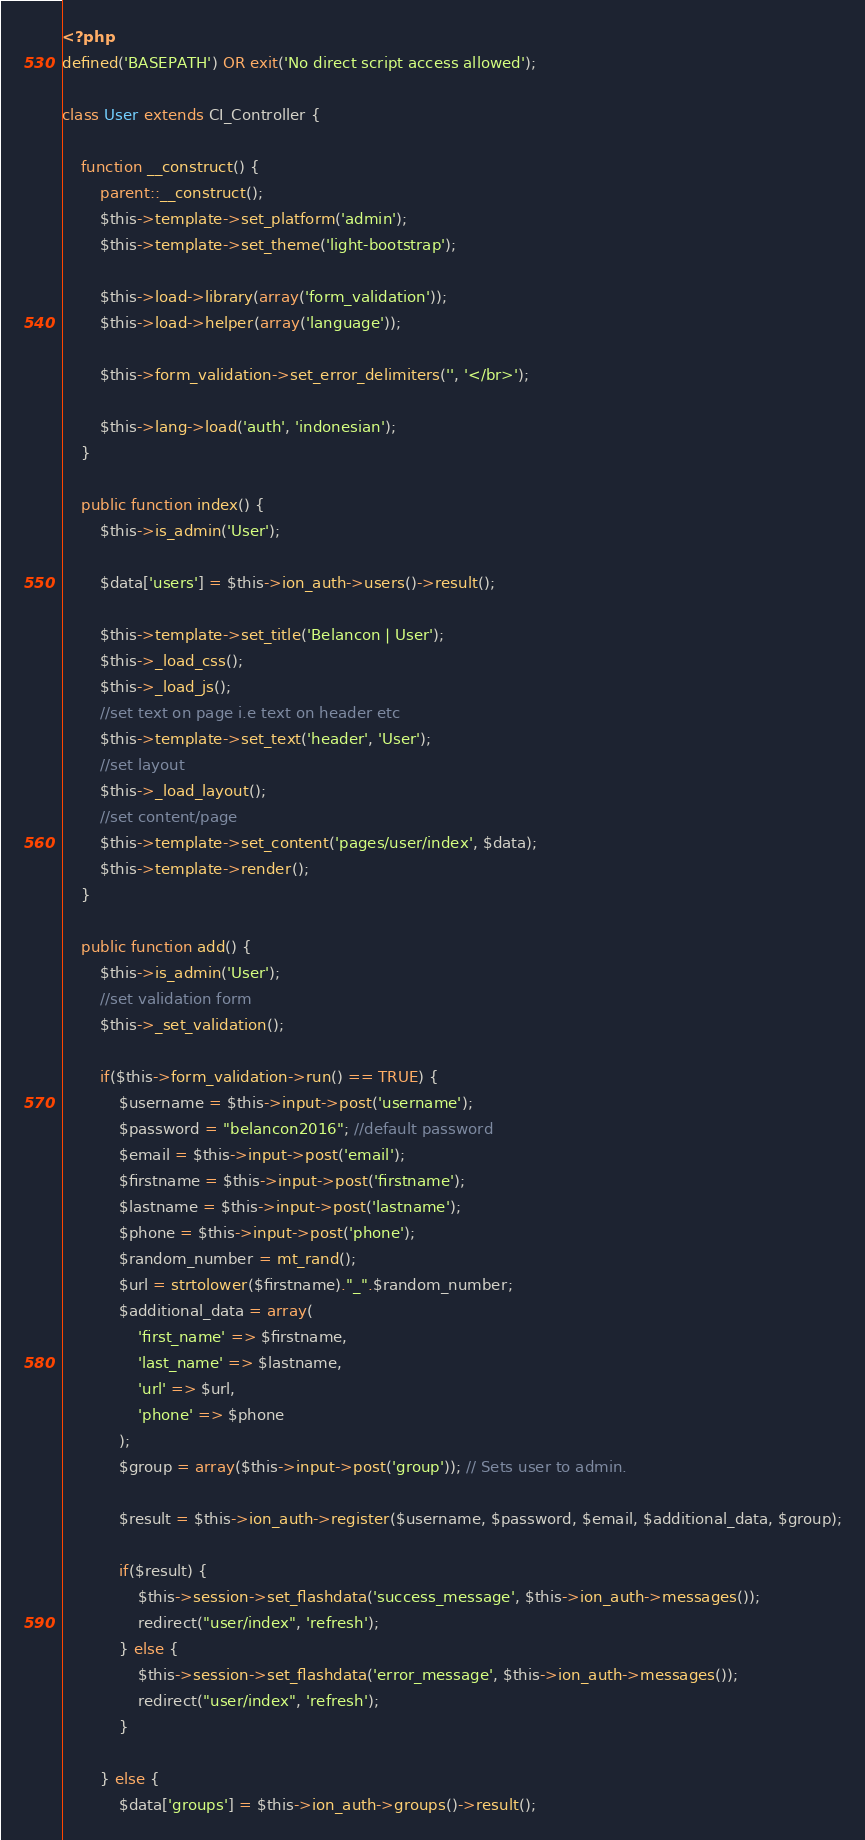Convert code to text. <code><loc_0><loc_0><loc_500><loc_500><_PHP_><?php
defined('BASEPATH') OR exit('No direct script access allowed');

class User extends CI_Controller {

	function __construct() {
		parent::__construct();
        $this->template->set_platform('admin');
        $this->template->set_theme('light-bootstrap');  

        $this->load->library(array('form_validation'));
        $this->load->helper(array('language'));

        $this->form_validation->set_error_delimiters('', '</br>');

        $this->lang->load('auth', 'indonesian');
	}

    public function index() {
        $this->is_admin('User');

        $data['users'] = $this->ion_auth->users()->result();

        $this->template->set_title('Belancon | User');
        $this->_load_css();
        $this->_load_js();
        //set text on page i.e text on header etc
        $this->template->set_text('header', 'User');
        //set layout
        $this->_load_layout();
        //set content/page
        $this->template->set_content('pages/user/index', $data);
        $this->template->render();
    }

    public function add() {
        $this->is_admin('User');
        //set validation form
        $this->_set_validation();

        if($this->form_validation->run() == TRUE) {
            $username = $this->input->post('username');
            $password = "belancon2016"; //default password
            $email = $this->input->post('email');
            $firstname = $this->input->post('firstname');
            $lastname = $this->input->post('lastname');
            $phone = $this->input->post('phone');
            $random_number = mt_rand();
            $url = strtolower($firstname)."_".$random_number;
            $additional_data = array(
                'first_name' => $firstname,
                'last_name' => $lastname,
                'url' => $url,
                'phone' => $phone
            );
            $group = array($this->input->post('group')); // Sets user to admin.
            
            $result = $this->ion_auth->register($username, $password, $email, $additional_data, $group);

            if($result) {
                $this->session->set_flashdata('success_message', $this->ion_auth->messages());
                redirect("user/index", 'refresh');
            } else {
                $this->session->set_flashdata('error_message', $this->ion_auth->messages());
                redirect("user/index", 'refresh');
            }

        } else {
            $data['groups'] = $this->ion_auth->groups()->result();</code> 